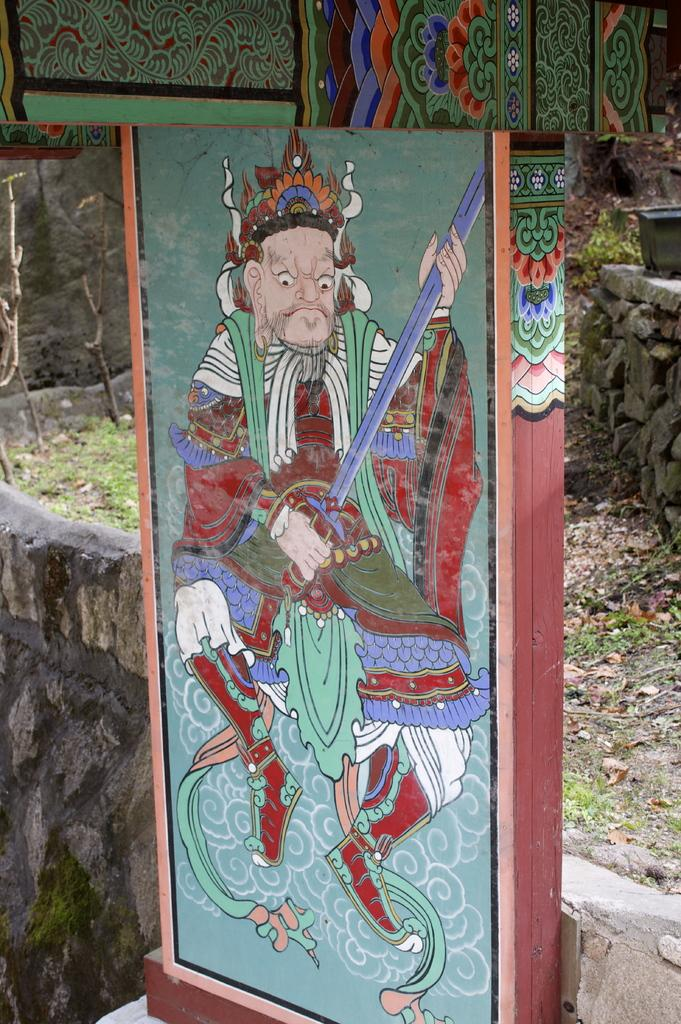What is depicted on the wooden board in the image? There is a painting on a wooden board in the image. What can be seen behind the wooden board? There are rocks visible behind the wooden board. What type of natural debris is present on the surface in the image? There are dry leaves on the surface in the image. What type of pet is visible in the image? There is no pet present in the image. Can you describe the swing in the image? There is no swing present in the image. 